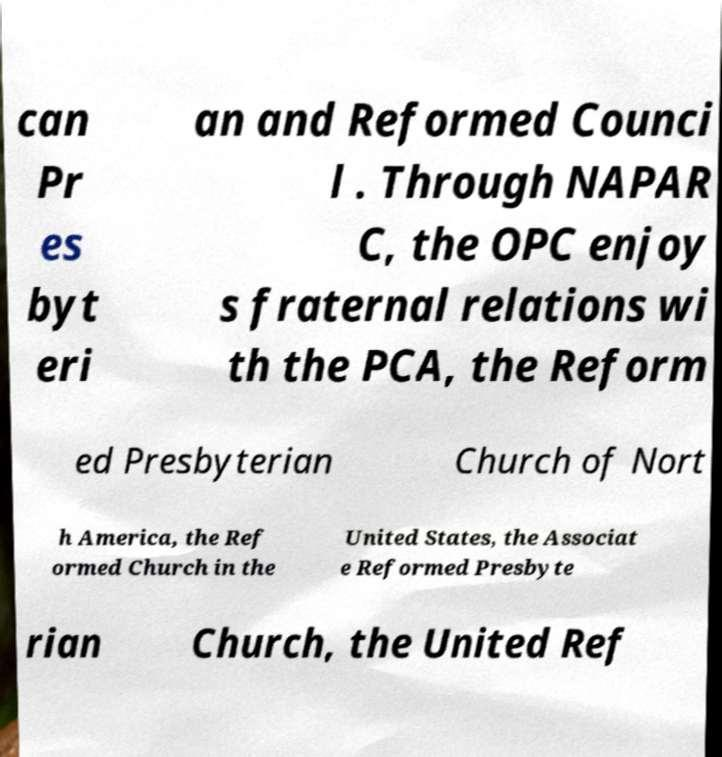Can you accurately transcribe the text from the provided image for me? can Pr es byt eri an and Reformed Counci l . Through NAPAR C, the OPC enjoy s fraternal relations wi th the PCA, the Reform ed Presbyterian Church of Nort h America, the Ref ormed Church in the United States, the Associat e Reformed Presbyte rian Church, the United Ref 